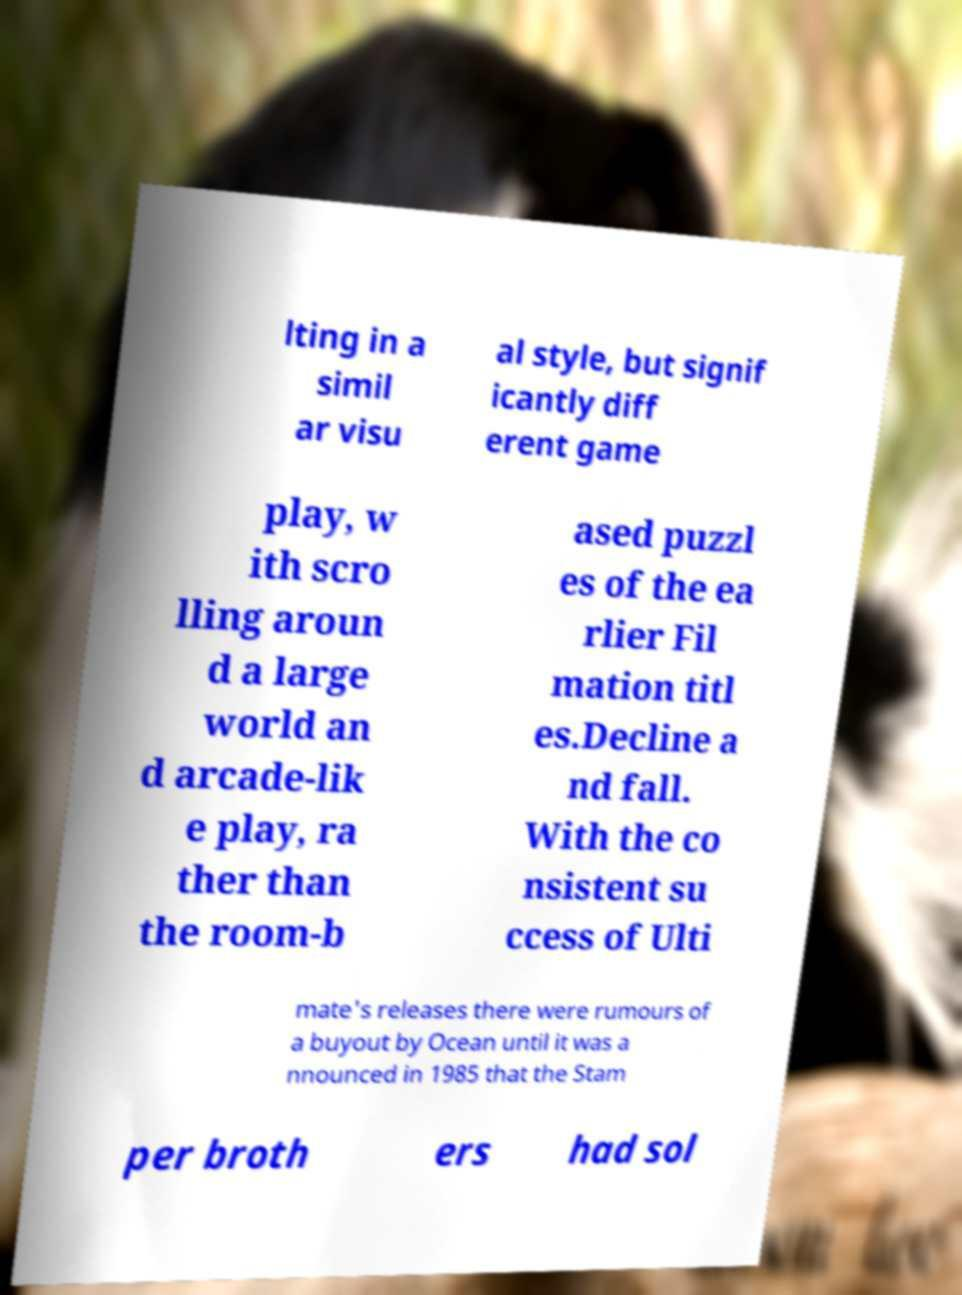There's text embedded in this image that I need extracted. Can you transcribe it verbatim? lting in a simil ar visu al style, but signif icantly diff erent game play, w ith scro lling aroun d a large world an d arcade-lik e play, ra ther than the room-b ased puzzl es of the ea rlier Fil mation titl es.Decline a nd fall. With the co nsistent su ccess of Ulti mate's releases there were rumours of a buyout by Ocean until it was a nnounced in 1985 that the Stam per broth ers had sol 